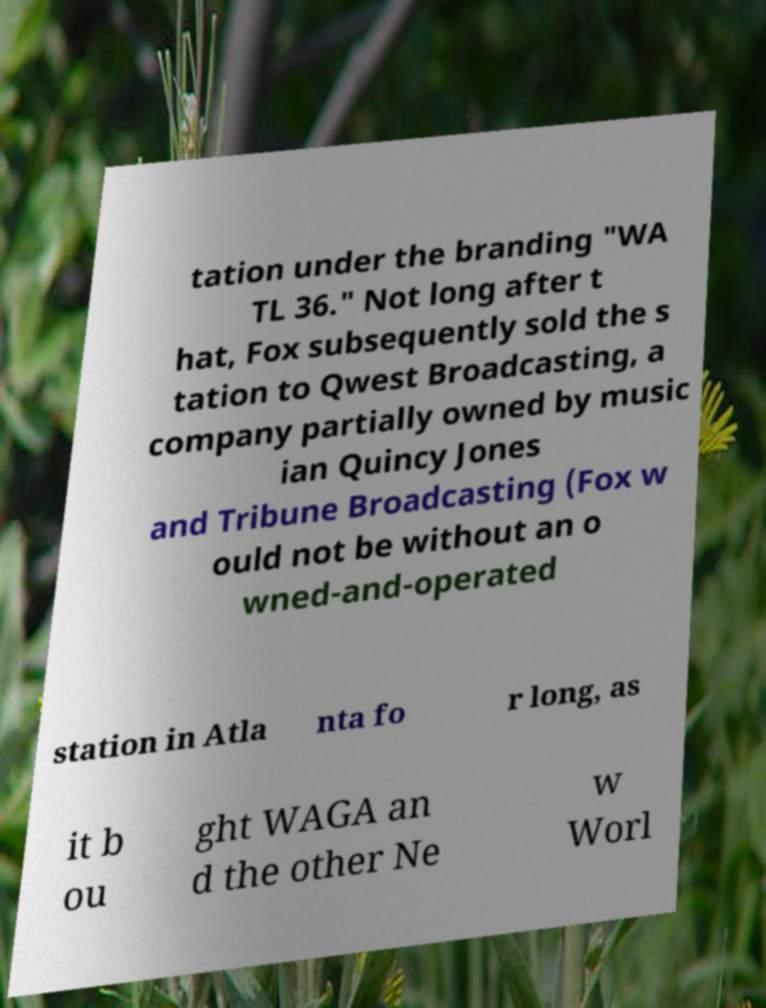Please identify and transcribe the text found in this image. tation under the branding "WA TL 36." Not long after t hat, Fox subsequently sold the s tation to Qwest Broadcasting, a company partially owned by music ian Quincy Jones and Tribune Broadcasting (Fox w ould not be without an o wned-and-operated station in Atla nta fo r long, as it b ou ght WAGA an d the other Ne w Worl 